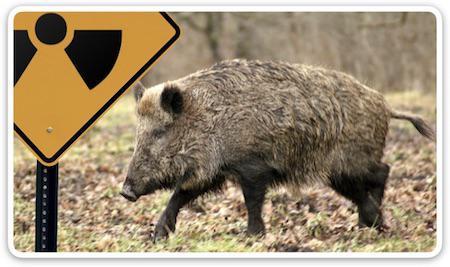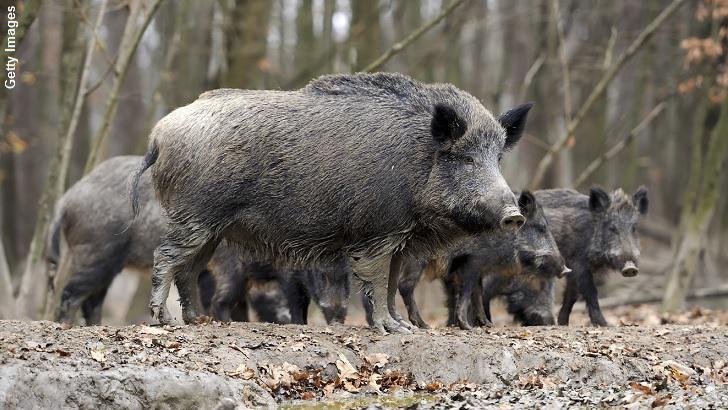The first image is the image on the left, the second image is the image on the right. Considering the images on both sides, is "The left image contains at least three times as many wild pigs as the right image." valid? Answer yes or no. No. The first image is the image on the left, the second image is the image on the right. For the images displayed, is the sentence "The image on the left shows a single warthog." factually correct? Answer yes or no. Yes. 